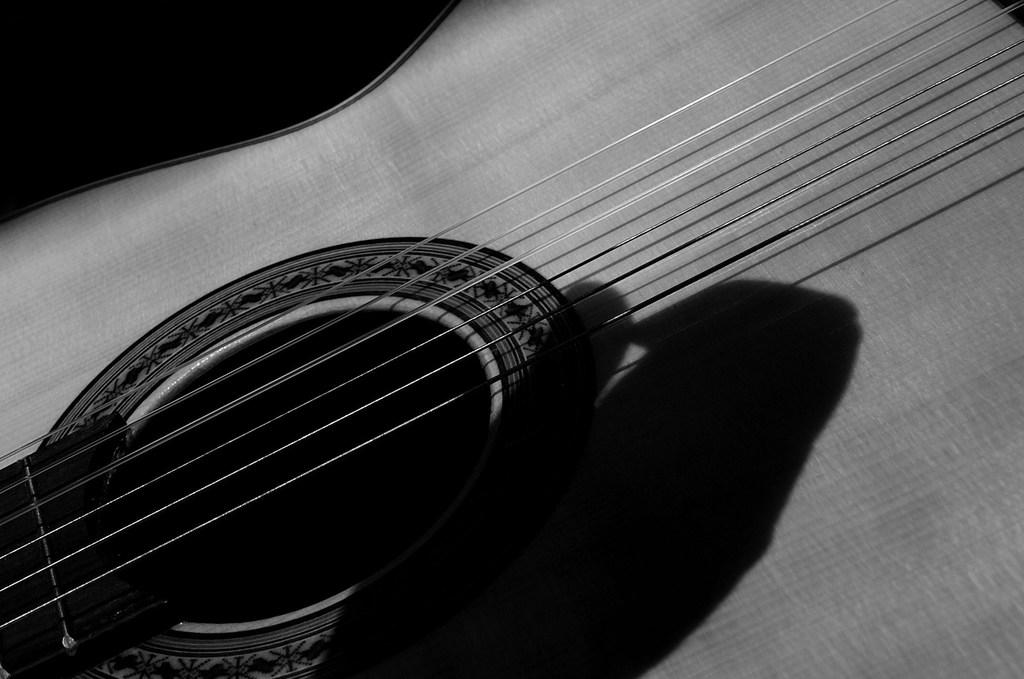What musical instrument is present in the image? There is a guitar in the image. What feature of the guitar is mentioned in the facts? The guitar has strings. What type of jewel is attached to the guitar's knee in the image? There is no mention of a knee or jewel in the image; the guitar has strings, but no reference to a jewel or any attachment to a knee. 